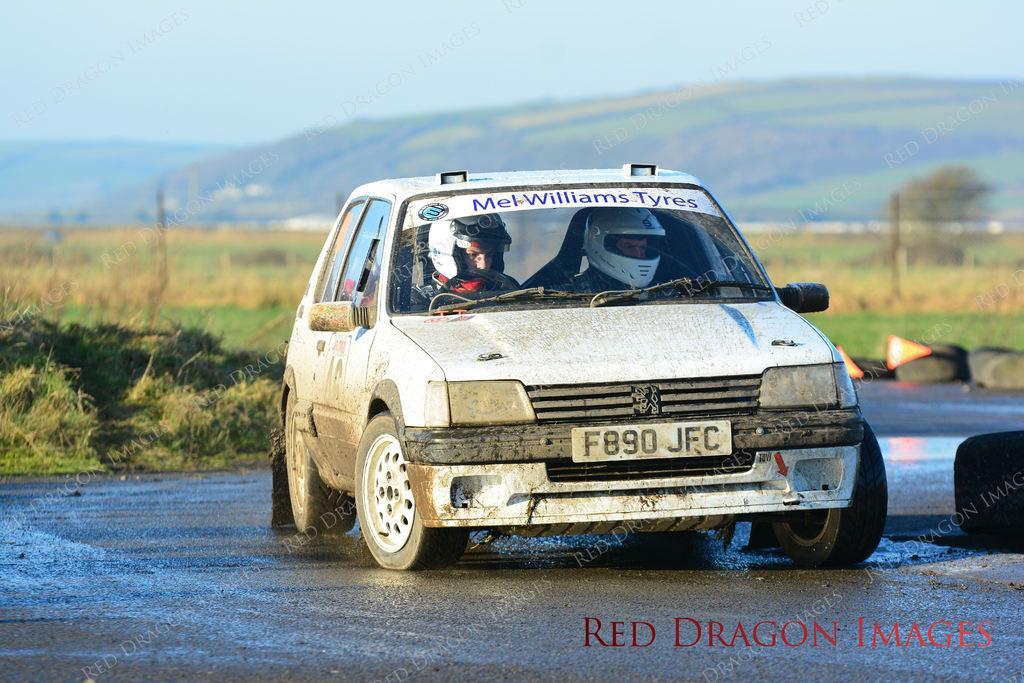Describe this image in one or two sentences. In this image we can see a car on the road, two men in the car, grass, sky and tires in the background. 